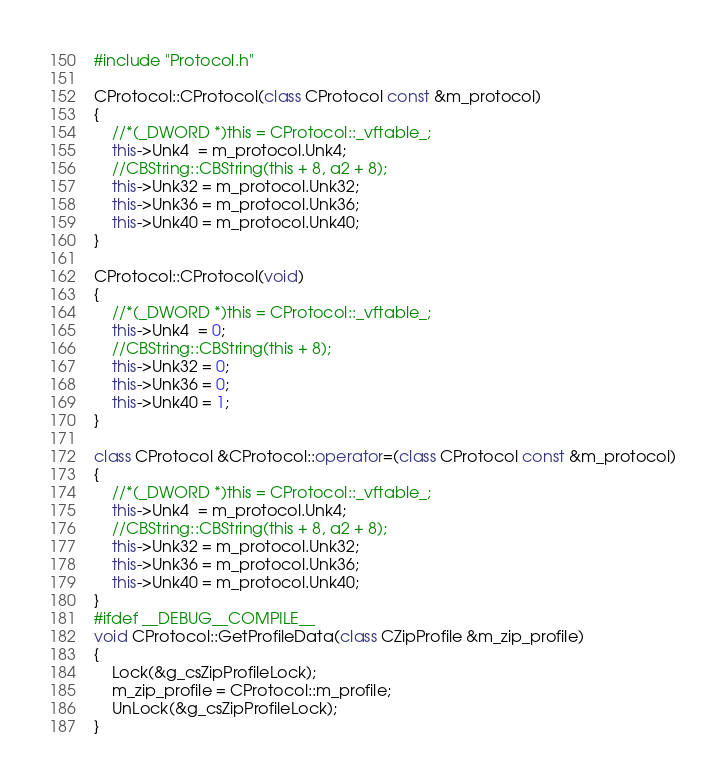<code> <loc_0><loc_0><loc_500><loc_500><_C++_>#include "Protocol.h"

CProtocol::CProtocol(class CProtocol const &m_protocol)
{
    //*(_DWORD *)this = CProtocol::_vftable_;
    this->Unk4  = m_protocol.Unk4;
    //CBString::CBString(this + 8, a2 + 8);
    this->Unk32 = m_protocol.Unk32;
    this->Unk36 = m_protocol.Unk36;
    this->Unk40 = m_protocol.Unk40;
}

CProtocol::CProtocol(void)
{
    //*(_DWORD *)this = CProtocol::_vftable_;
    this->Unk4  = 0;
    //CBString::CBString(this + 8);
    this->Unk32 = 0;
    this->Unk36 = 0;
    this->Unk40 = 1;
}

class CProtocol &CProtocol::operator=(class CProtocol const &m_protocol)
{
    //*(_DWORD *)this = CProtocol::_vftable_;
    this->Unk4  = m_protocol.Unk4;
    //CBString::CBString(this + 8, a2 + 8);
    this->Unk32 = m_protocol.Unk32;
    this->Unk36 = m_protocol.Unk36;
    this->Unk40 = m_protocol.Unk40;
}
#ifdef __DEBUG__COMPILE__
void CProtocol::GetProfileData(class CZipProfile &m_zip_profile)
{
    Lock(&g_csZipProfileLock);
    m_zip_profile = CProtocol::m_profile;
    UnLock(&g_csZipProfileLock);
}
</code> 